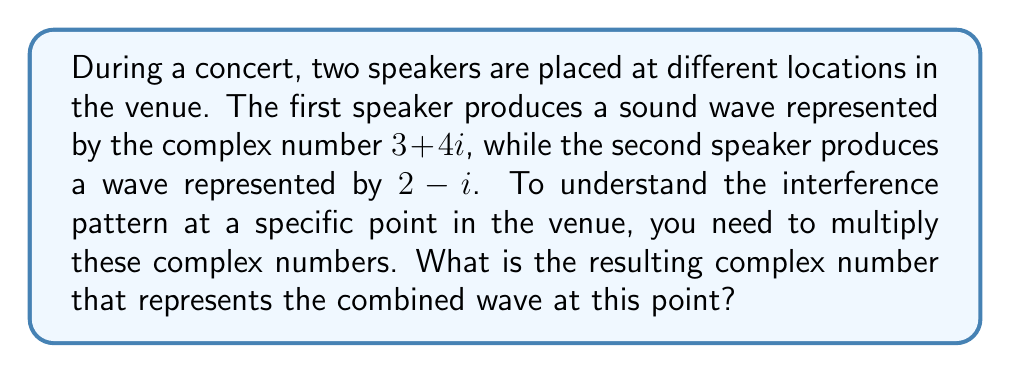Could you help me with this problem? Let's approach this step-by-step:

1) We need to multiply the two complex numbers: $(3 + 4i)(2 - i)$

2) To multiply complex numbers, we use the distributive property and the fact that $i^2 = -1$:

   $$(3 + 4i)(2 - i) = 3(2 - i) + 4i(2 - i)$$

3) Let's expand this:

   $$= (6 - 3i) + (8i - 4i^2)$$

4) Simplify, remembering that $i^2 = -1$:

   $$= 6 - 3i + 8i + 4$$

5) Combine like terms:

   $$= 10 + 5i$$

This resulting complex number represents the combined wave at the specific point in the venue. The real part (10) represents the amplitude of the resultant wave, while the imaginary part (5) represents the phase shift.
Answer: $10 + 5i$ 